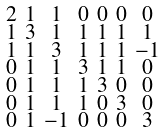<formula> <loc_0><loc_0><loc_500><loc_500>\begin{smallmatrix} 2 & 1 & 1 & 0 & 0 & 0 & 0 \\ 1 & 3 & 1 & 1 & 1 & 1 & 1 \\ 1 & 1 & 3 & 1 & 1 & 1 & - 1 \\ 0 & 1 & 1 & 3 & 1 & 1 & 0 \\ 0 & 1 & 1 & 1 & 3 & 0 & 0 \\ 0 & 1 & 1 & 1 & 0 & 3 & 0 \\ 0 & 1 & - 1 & 0 & 0 & 0 & 3 \end{smallmatrix}</formula> 